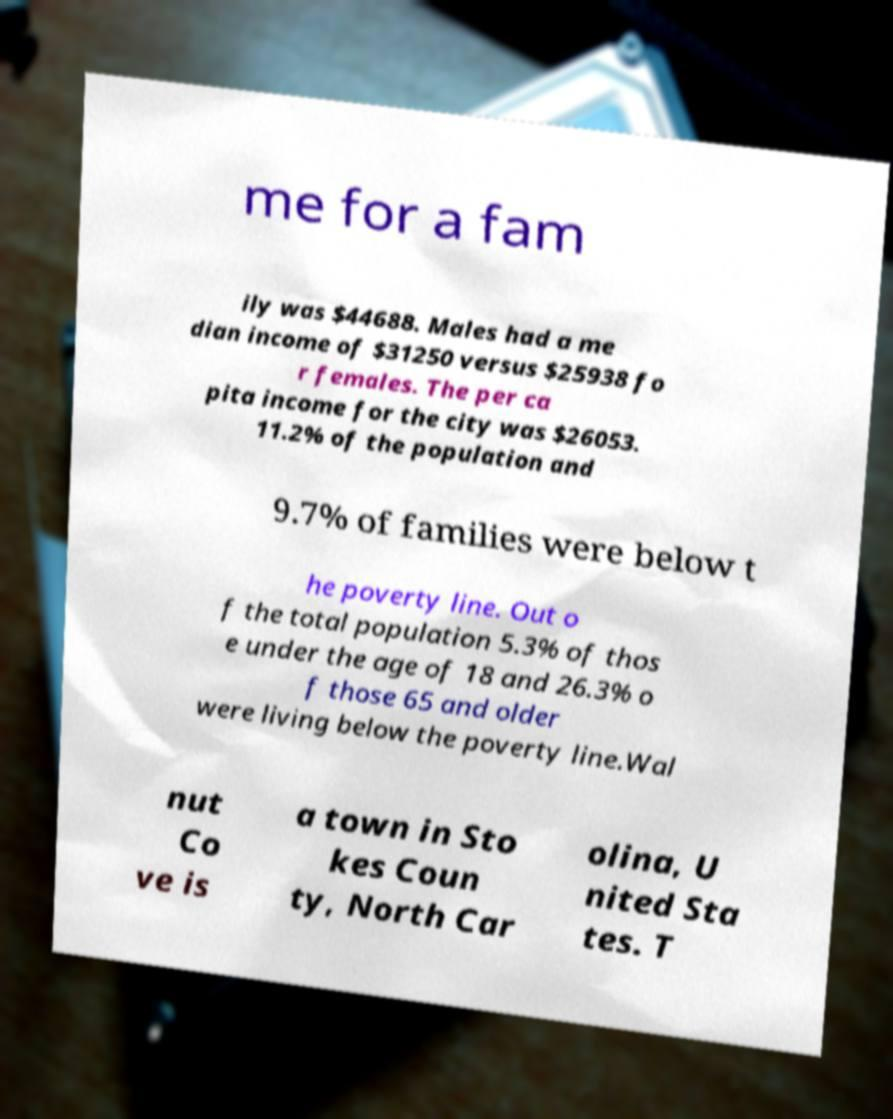Please identify and transcribe the text found in this image. me for a fam ily was $44688. Males had a me dian income of $31250 versus $25938 fo r females. The per ca pita income for the city was $26053. 11.2% of the population and 9.7% of families were below t he poverty line. Out o f the total population 5.3% of thos e under the age of 18 and 26.3% o f those 65 and older were living below the poverty line.Wal nut Co ve is a town in Sto kes Coun ty, North Car olina, U nited Sta tes. T 